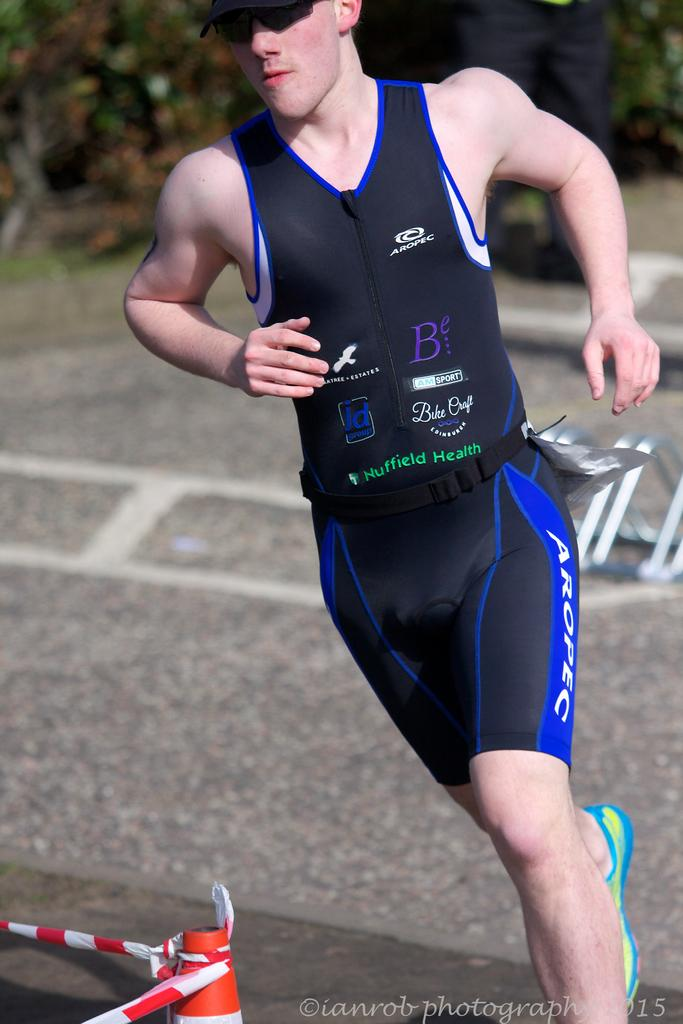<image>
Share a concise interpretation of the image provided. a person running with the letter B on their outfit 